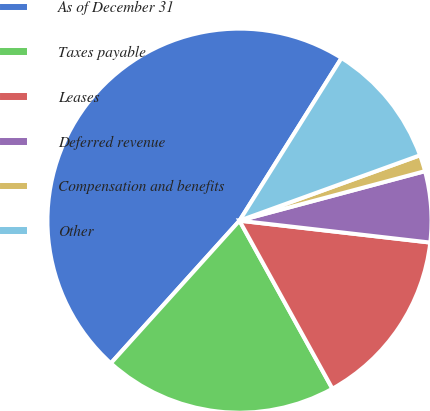Convert chart. <chart><loc_0><loc_0><loc_500><loc_500><pie_chart><fcel>As of December 31<fcel>Taxes payable<fcel>Leases<fcel>Deferred revenue<fcel>Compensation and benefits<fcel>Other<nl><fcel>47.23%<fcel>19.72%<fcel>15.14%<fcel>5.97%<fcel>1.38%<fcel>10.55%<nl></chart> 